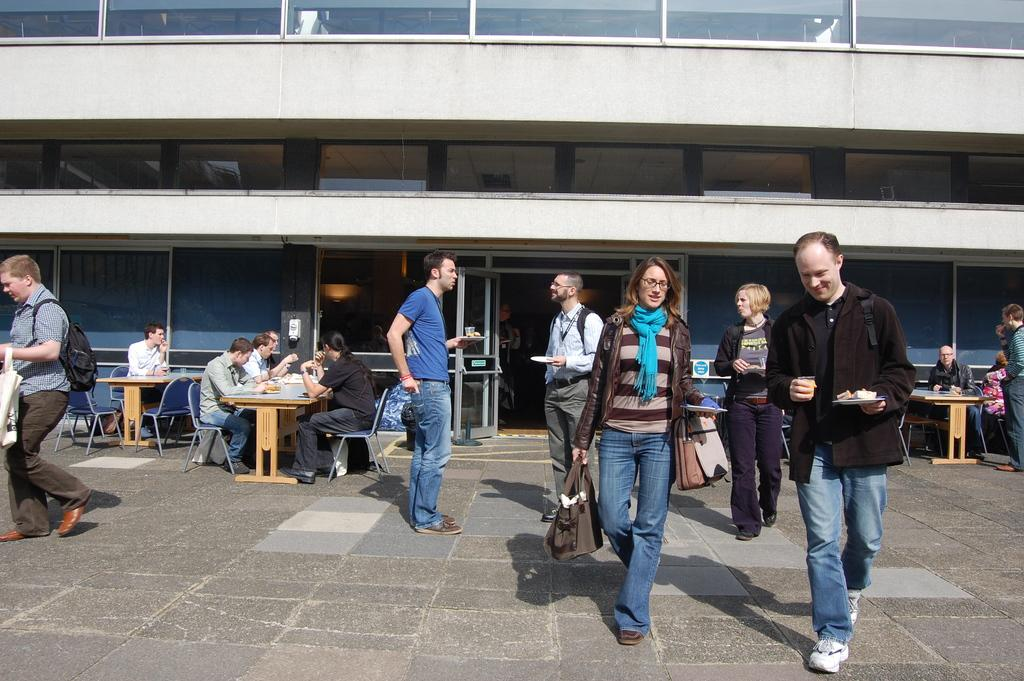What is the main subject of the image? The main subject of the image is a group of people. What are some of the people in the image doing? Some people are sitting on chairs, some are standing, and some are walking on the ground. What can be seen in the background of the image? There is a building in the background of the image. What type of wine is being served to the people in the image? There is no wine present in the image; it features a group of people with various positions and actions. What suggestion is being made by the person holding the gun in the image? There is no gun present in the image, and therefore no suggestion can be made by someone holding a gun. 